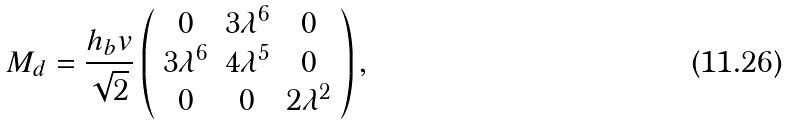Convert formula to latex. <formula><loc_0><loc_0><loc_500><loc_500>M _ { d } = \frac { h _ { b } v } { \sqrt { 2 } } \left ( \begin{array} { c c c } 0 & 3 \lambda ^ { 6 } & 0 \\ 3 \lambda ^ { 6 } & 4 \lambda ^ { 5 } & 0 \\ 0 & 0 & 2 \lambda ^ { 2 } \end{array} \right ) ,</formula> 